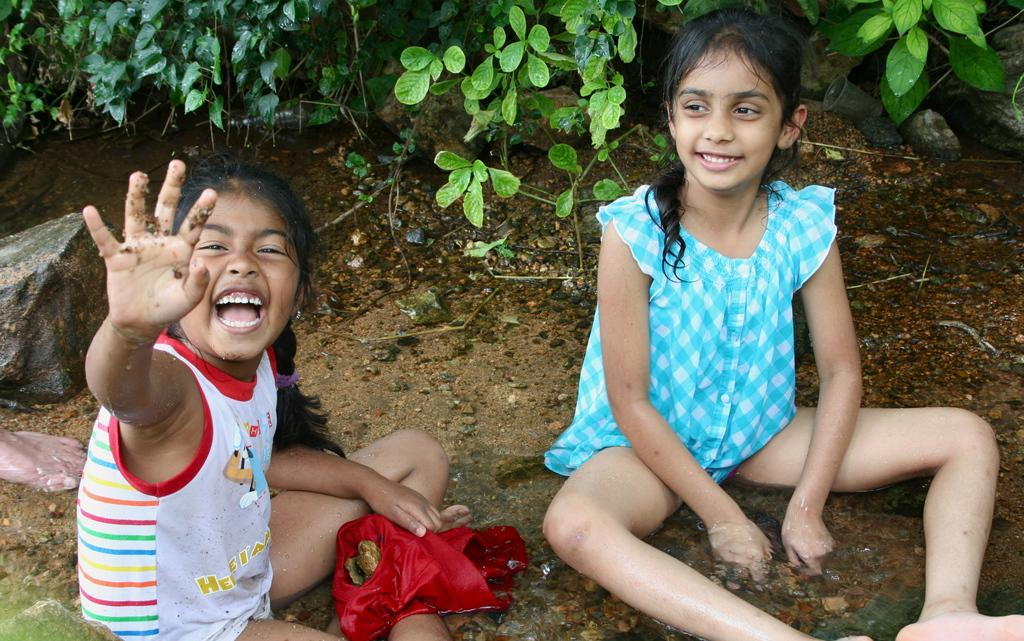What is on the sand in the image? There is water on the sand in the image. What are the two girls doing in the image? The two girls are sitting and playing with water. What is one of the girls holding? One girl is holding a cloth. What can be seen in the background of the image? There are plants and rocks visible in the background of the image. Where is the wax market located in the image? There is no wax market present in the image. What day of the week is it in the image? The day of the week cannot be determined from the image. 